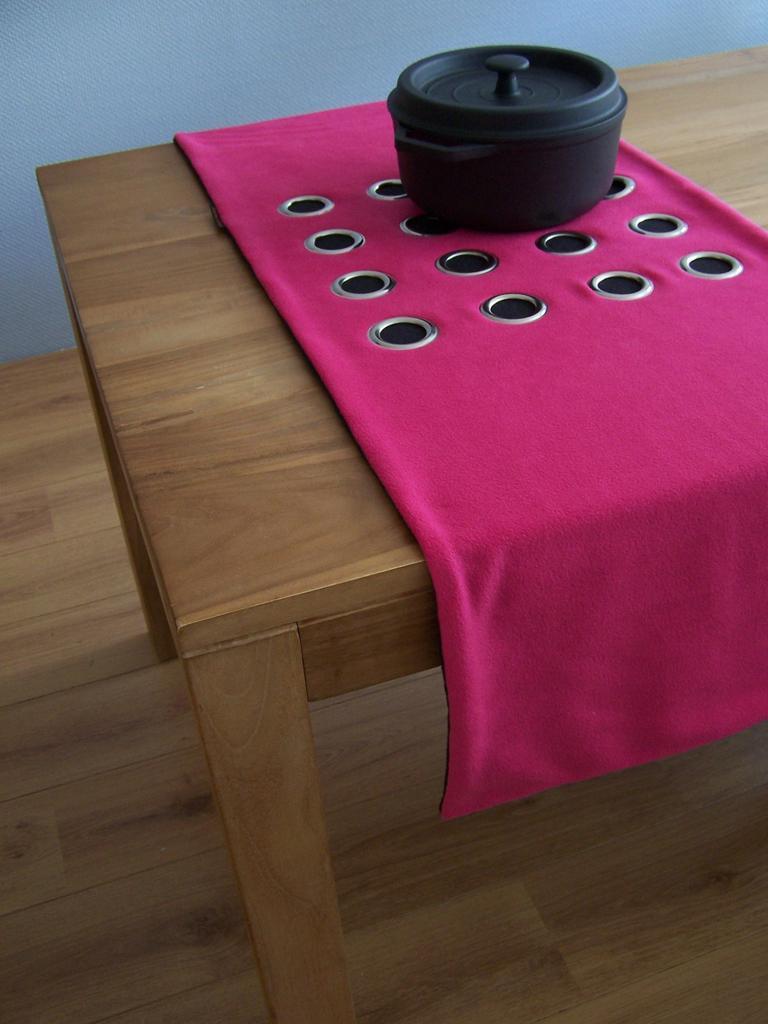Please provide a concise description of this image. In this picture we can observe a pink color cloth on the brown color table. There is a black color box on the cloth. In the background there is a wall. 